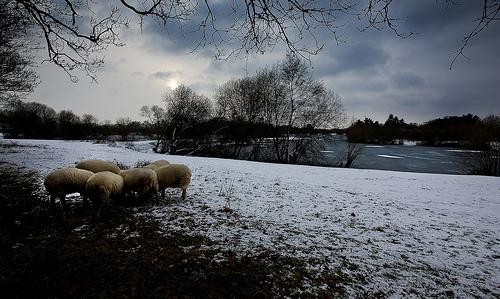Describe any structures or buildings that are visible in the image. There is a small house in the background of the image. Identify and describe the main animals present in the image and their behavior. The image features a herd of white sheep that are all together, grazing on snow covered ground, and eating grass. What elements in the image suggest that the season might be winter? The lightly snow covered ground, frozen pond, and trees that have lost their leaves indicate it might be winter. Please talk about the physical features of the sheep and their appearance. The sheep are white, they have been sheared, and one of the sheep has no tail. Describe the presence of nature and weather in this image. The image has a cloudy grey sky, sun shining through, and the ground covered by white snow and brown leaves. Could you provide a summary of the trees and landscape in the image? The image has a brown tree, small tree limb, branches, and all trees have lost their leaves. There's a frozen pond, a hill, and a small house in the background. How would you describe the visibility of the sun and sky in the image? The sun is shining through, but the sky is cloudy, gray, and stormy with gray and white clouds against a blue sky. Can you tell me the overall scene captured in this image, along with the condition of the ground? The image shows a group of sheep grazing on lightly snow covered ground, with some brown leaves scattered about. In the context of the image, what can be said about the snow and the ground's condition? The snow seems to be melting, and the ground is covered by white snow and brown leaves. What is the main activity being carried out by the sheep in the image? The sheep are grazing on snow covered ground. 